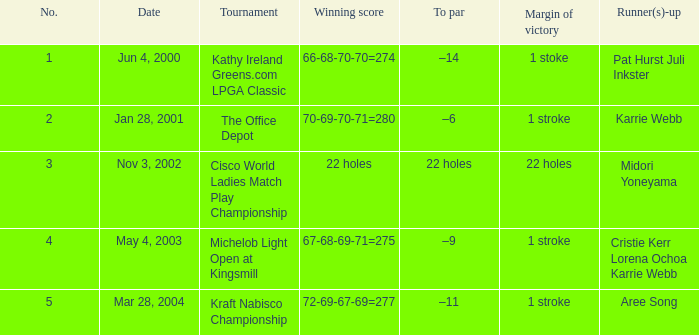What date were the runner ups pat hurst juli inkster? Jun 4, 2000. 